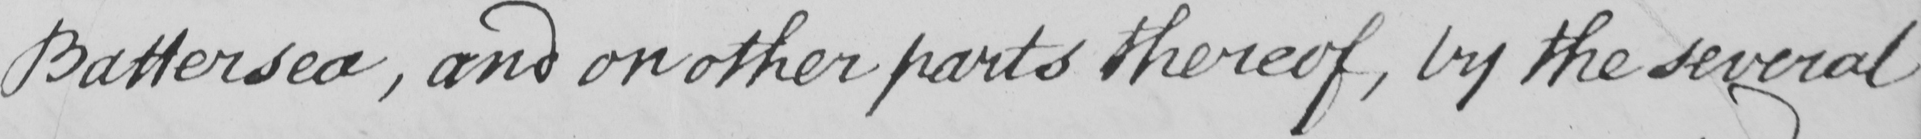Can you tell me what this handwritten text says? Battersea , and on other parts thereof , by the several 